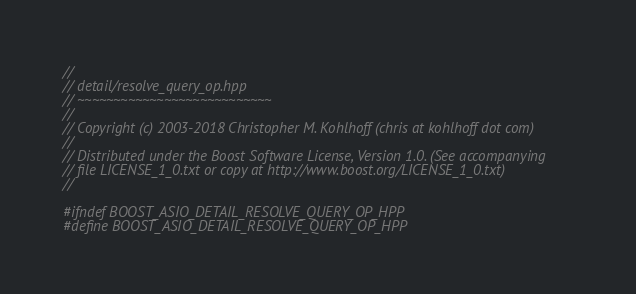Convert code to text. <code><loc_0><loc_0><loc_500><loc_500><_C++_>//
// detail/resolve_query_op.hpp
// ~~~~~~~~~~~~~~~~~~~~~~~~~~~
//
// Copyright (c) 2003-2018 Christopher M. Kohlhoff (chris at kohlhoff dot com)
//
// Distributed under the Boost Software License, Version 1.0. (See accompanying
// file LICENSE_1_0.txt or copy at http://www.boost.org/LICENSE_1_0.txt)
//

#ifndef BOOST_ASIO_DETAIL_RESOLVE_QUERY_OP_HPP
#define BOOST_ASIO_DETAIL_RESOLVE_QUERY_OP_HPP
</code> 